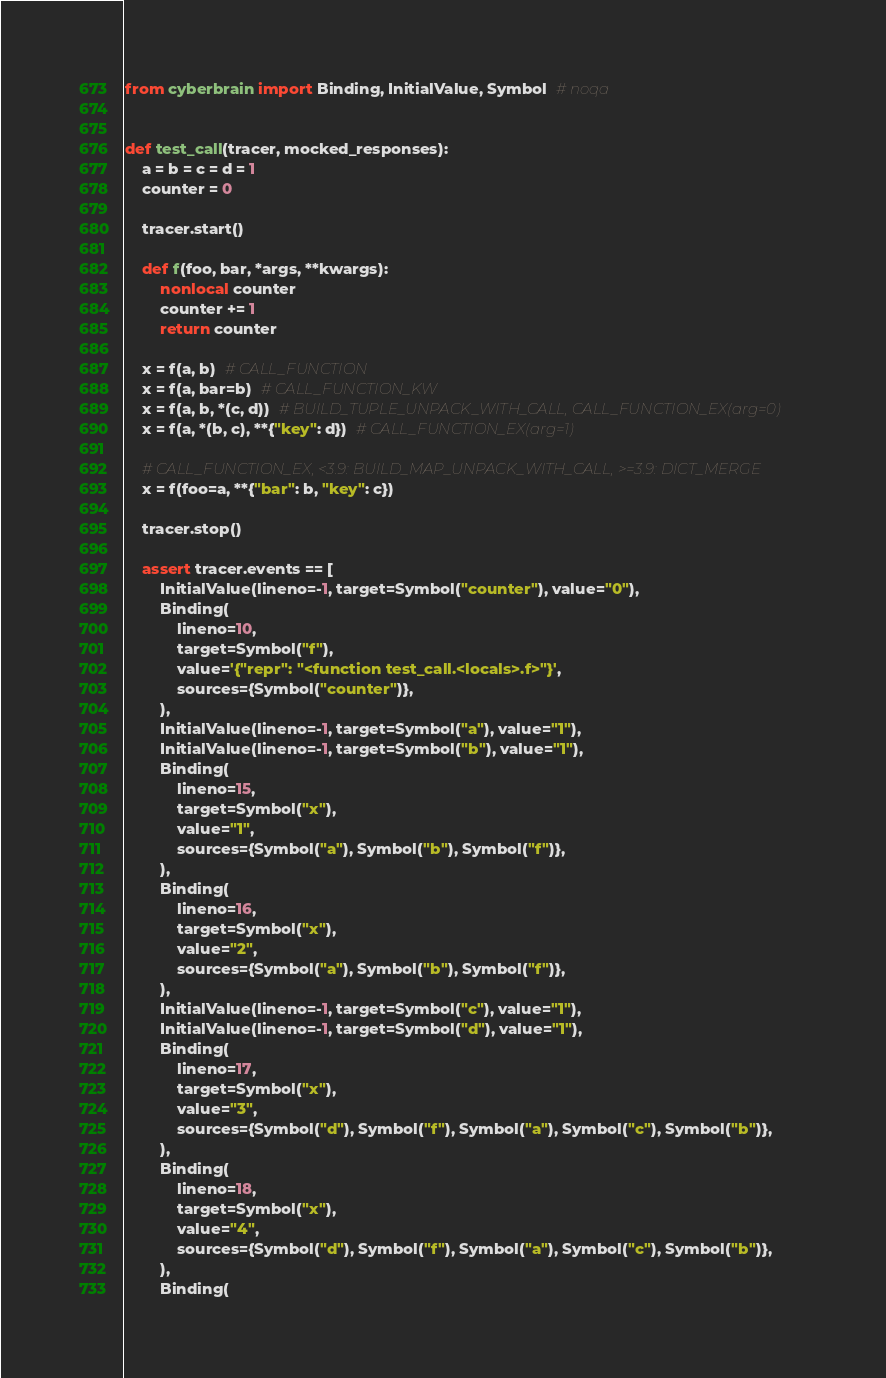<code> <loc_0><loc_0><loc_500><loc_500><_Python_>from cyberbrain import Binding, InitialValue, Symbol  # noqa


def test_call(tracer, mocked_responses):
    a = b = c = d = 1
    counter = 0

    tracer.start()

    def f(foo, bar, *args, **kwargs):
        nonlocal counter
        counter += 1
        return counter

    x = f(a, b)  # CALL_FUNCTION
    x = f(a, bar=b)  # CALL_FUNCTION_KW
    x = f(a, b, *(c, d))  # BUILD_TUPLE_UNPACK_WITH_CALL, CALL_FUNCTION_EX(arg=0)
    x = f(a, *(b, c), **{"key": d})  # CALL_FUNCTION_EX(arg=1)

    # CALL_FUNCTION_EX, <3.9: BUILD_MAP_UNPACK_WITH_CALL, >=3.9: DICT_MERGE
    x = f(foo=a, **{"bar": b, "key": c})

    tracer.stop()

    assert tracer.events == [
        InitialValue(lineno=-1, target=Symbol("counter"), value="0"),
        Binding(
            lineno=10,
            target=Symbol("f"),
            value='{"repr": "<function test_call.<locals>.f>"}',
            sources={Symbol("counter")},
        ),
        InitialValue(lineno=-1, target=Symbol("a"), value="1"),
        InitialValue(lineno=-1, target=Symbol("b"), value="1"),
        Binding(
            lineno=15,
            target=Symbol("x"),
            value="1",
            sources={Symbol("a"), Symbol("b"), Symbol("f")},
        ),
        Binding(
            lineno=16,
            target=Symbol("x"),
            value="2",
            sources={Symbol("a"), Symbol("b"), Symbol("f")},
        ),
        InitialValue(lineno=-1, target=Symbol("c"), value="1"),
        InitialValue(lineno=-1, target=Symbol("d"), value="1"),
        Binding(
            lineno=17,
            target=Symbol("x"),
            value="3",
            sources={Symbol("d"), Symbol("f"), Symbol("a"), Symbol("c"), Symbol("b")},
        ),
        Binding(
            lineno=18,
            target=Symbol("x"),
            value="4",
            sources={Symbol("d"), Symbol("f"), Symbol("a"), Symbol("c"), Symbol("b")},
        ),
        Binding(</code> 